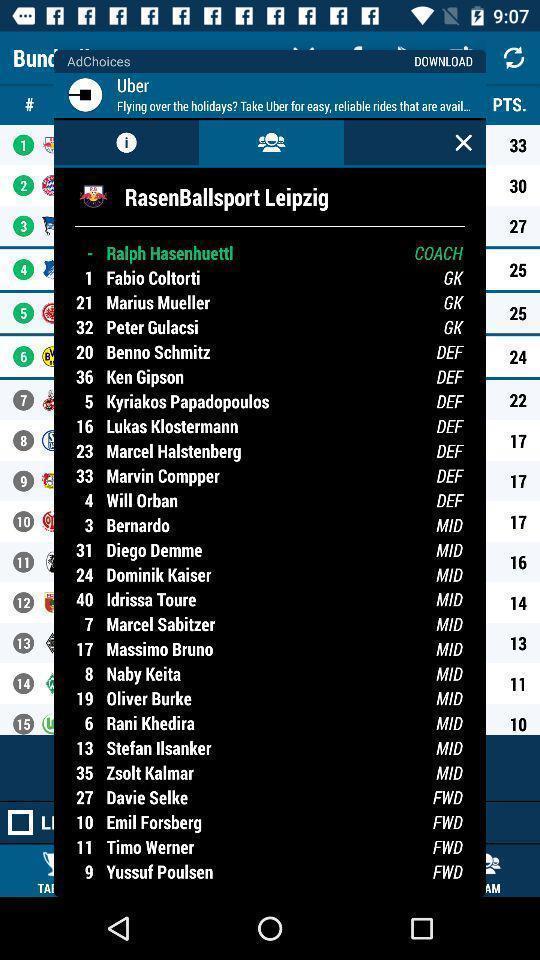Provide a textual representation of this image. Screen displaying the player listings. 